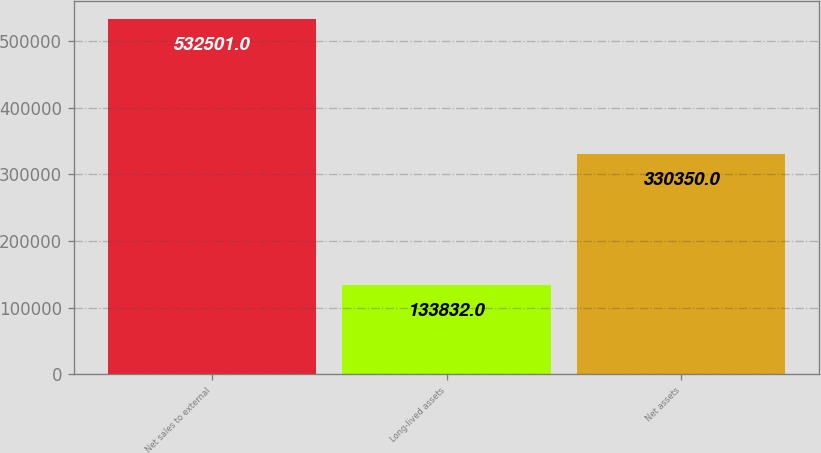Convert chart to OTSL. <chart><loc_0><loc_0><loc_500><loc_500><bar_chart><fcel>Net sales to external<fcel>Long-lived assets<fcel>Net assets<nl><fcel>532501<fcel>133832<fcel>330350<nl></chart> 